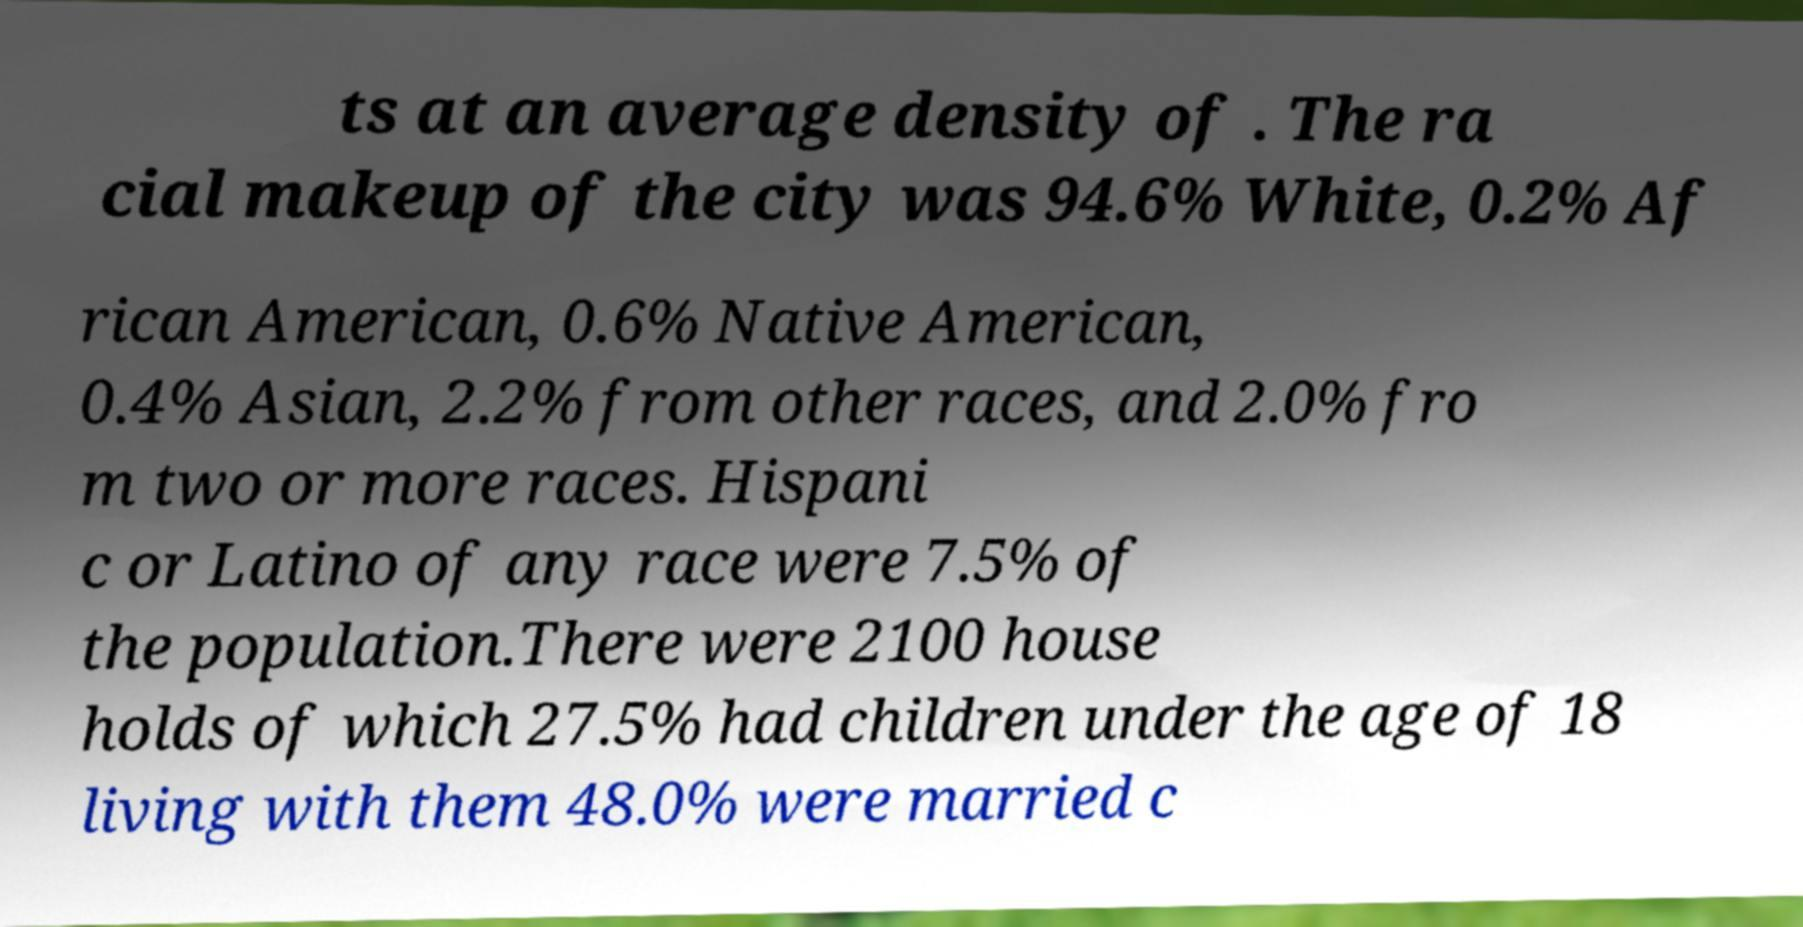What messages or text are displayed in this image? I need them in a readable, typed format. ts at an average density of . The ra cial makeup of the city was 94.6% White, 0.2% Af rican American, 0.6% Native American, 0.4% Asian, 2.2% from other races, and 2.0% fro m two or more races. Hispani c or Latino of any race were 7.5% of the population.There were 2100 house holds of which 27.5% had children under the age of 18 living with them 48.0% were married c 